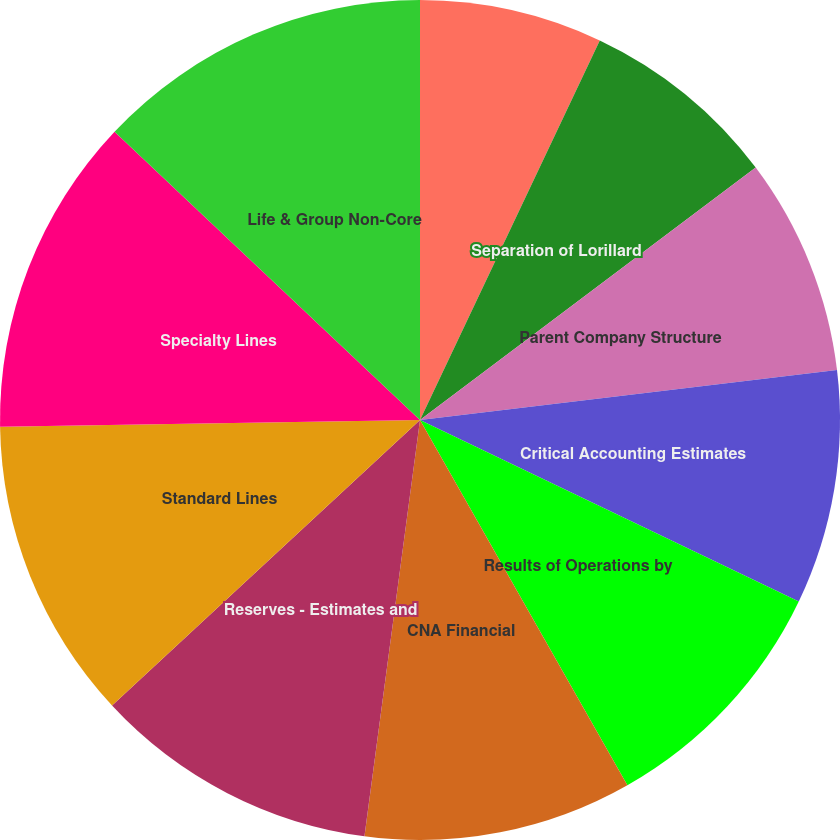<chart> <loc_0><loc_0><loc_500><loc_500><pie_chart><fcel>Consolidated Financial Results<fcel>Separation of Lorillard<fcel>Parent Company Structure<fcel>Critical Accounting Estimates<fcel>Results of Operations by<fcel>CNA Financial<fcel>Reserves - Estimates and<fcel>Standard Lines<fcel>Specialty Lines<fcel>Life & Group Non-Core<nl><fcel>7.04%<fcel>7.7%<fcel>8.36%<fcel>9.01%<fcel>9.67%<fcel>10.33%<fcel>10.99%<fcel>11.64%<fcel>12.3%<fcel>12.96%<nl></chart> 